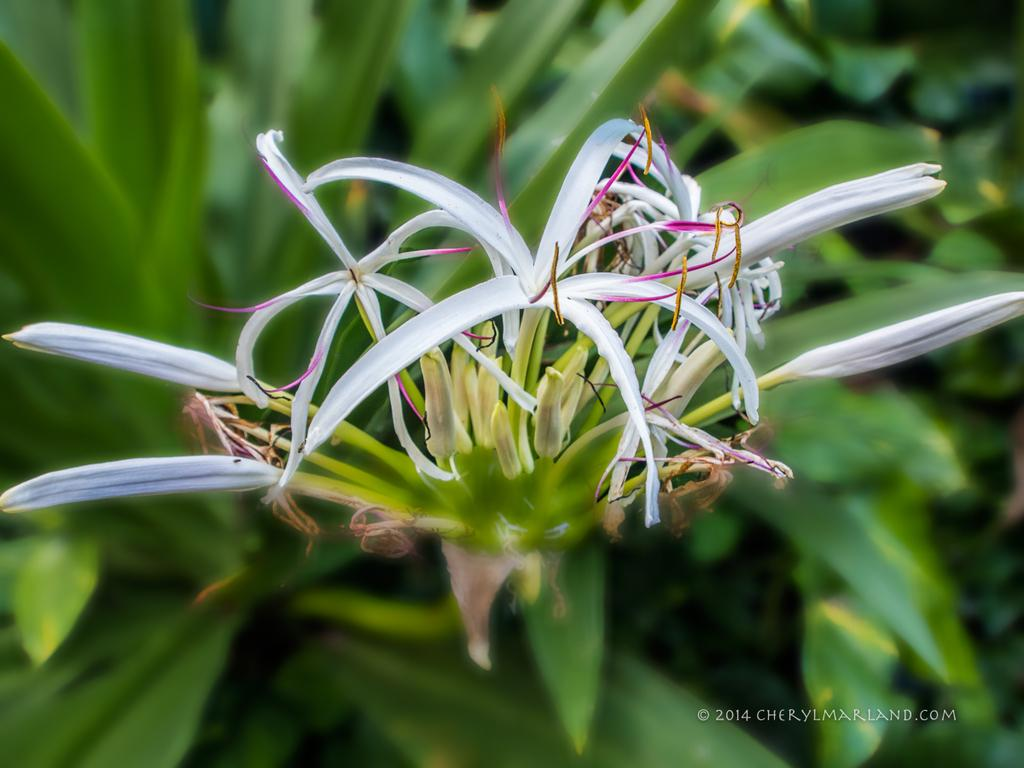What is the main subject in the center of the image? There are flowers in the center of the image. What other plant-related objects can be seen at the bottom of the image? There are plants at the bottom of the image. What type of crime is being committed in the image? There is no crime present in the image; it features flowers and plants. What question is being asked in the image? There is no question present in the image; it is a still image of flowers and plants. 